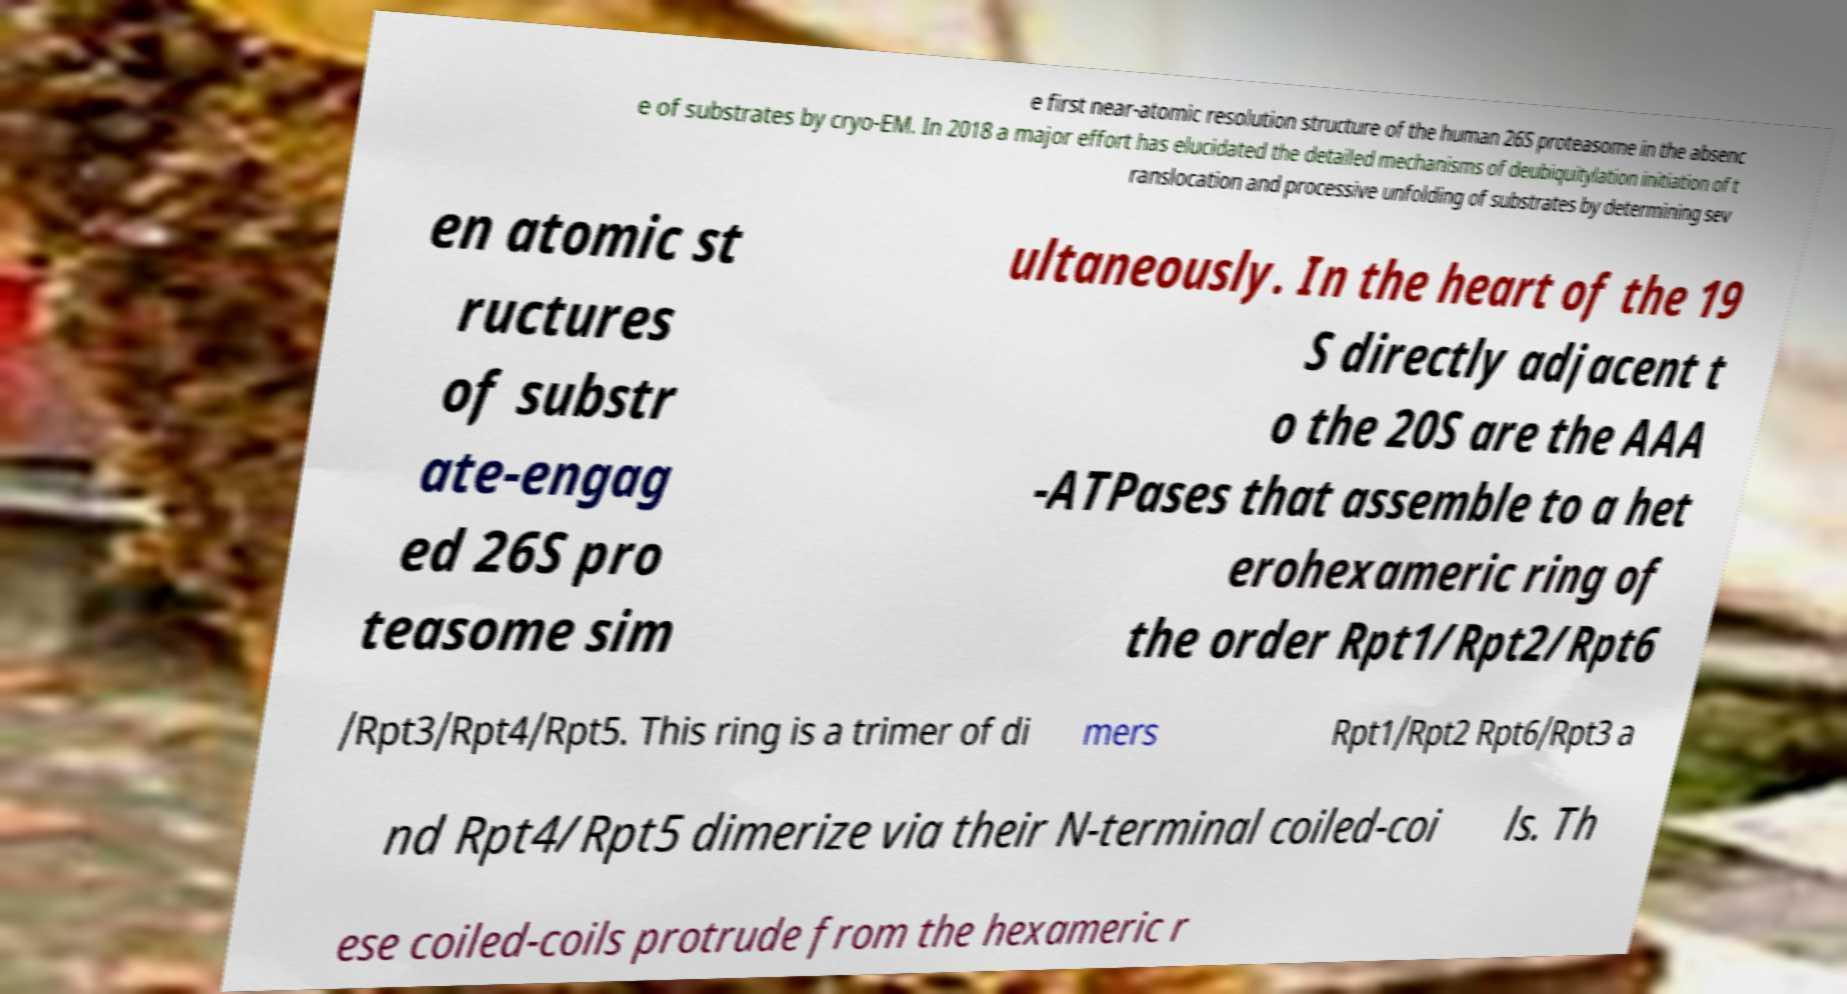Could you assist in decoding the text presented in this image and type it out clearly? e first near-atomic resolution structure of the human 26S proteasome in the absenc e of substrates by cryo-EM. In 2018 a major effort has elucidated the detailed mechanisms of deubiquitylation initiation of t ranslocation and processive unfolding of substrates by determining sev en atomic st ructures of substr ate-engag ed 26S pro teasome sim ultaneously. In the heart of the 19 S directly adjacent t o the 20S are the AAA -ATPases that assemble to a het erohexameric ring of the order Rpt1/Rpt2/Rpt6 /Rpt3/Rpt4/Rpt5. This ring is a trimer of di mers Rpt1/Rpt2 Rpt6/Rpt3 a nd Rpt4/Rpt5 dimerize via their N-terminal coiled-coi ls. Th ese coiled-coils protrude from the hexameric r 